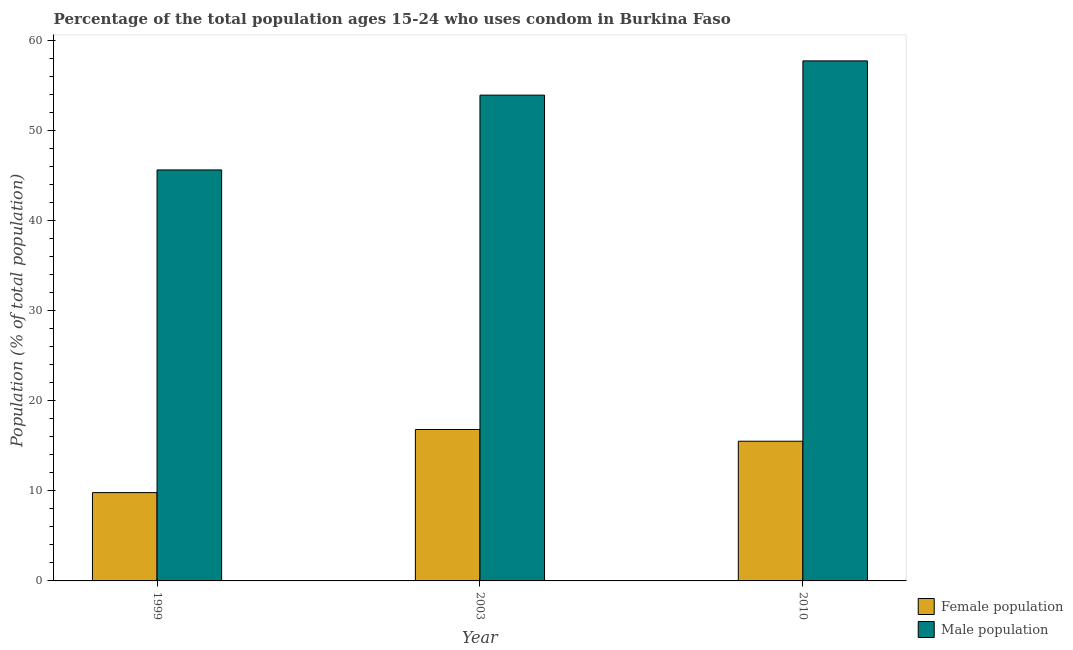How many groups of bars are there?
Ensure brevity in your answer.  3. Are the number of bars per tick equal to the number of legend labels?
Offer a terse response. Yes. Are the number of bars on each tick of the X-axis equal?
Give a very brief answer. Yes. How many bars are there on the 3rd tick from the left?
Provide a short and direct response. 2. In how many cases, is the number of bars for a given year not equal to the number of legend labels?
Give a very brief answer. 0. What is the female population in 2010?
Ensure brevity in your answer.  15.5. Across all years, what is the maximum male population?
Provide a short and direct response. 57.7. In which year was the female population minimum?
Keep it short and to the point. 1999. What is the total female population in the graph?
Provide a succinct answer. 42.1. What is the difference between the male population in 1999 and that in 2003?
Your response must be concise. -8.3. What is the difference between the male population in 2010 and the female population in 2003?
Give a very brief answer. 3.8. What is the average female population per year?
Provide a short and direct response. 14.03. In the year 2003, what is the difference between the male population and female population?
Your answer should be compact. 0. In how many years, is the female population greater than 12 %?
Your response must be concise. 2. What is the ratio of the male population in 1999 to that in 2003?
Offer a very short reply. 0.85. Is the difference between the male population in 1999 and 2010 greater than the difference between the female population in 1999 and 2010?
Your response must be concise. No. What is the difference between the highest and the second highest female population?
Offer a terse response. 1.3. What is the difference between the highest and the lowest male population?
Keep it short and to the point. 12.1. In how many years, is the female population greater than the average female population taken over all years?
Offer a very short reply. 2. What does the 1st bar from the left in 2003 represents?
Ensure brevity in your answer.  Female population. What does the 1st bar from the right in 2003 represents?
Ensure brevity in your answer.  Male population. How many bars are there?
Provide a succinct answer. 6. Are all the bars in the graph horizontal?
Provide a short and direct response. No. What is the difference between two consecutive major ticks on the Y-axis?
Make the answer very short. 10. How are the legend labels stacked?
Your response must be concise. Vertical. What is the title of the graph?
Provide a short and direct response. Percentage of the total population ages 15-24 who uses condom in Burkina Faso. What is the label or title of the X-axis?
Your response must be concise. Year. What is the label or title of the Y-axis?
Give a very brief answer. Population (% of total population) . What is the Population (% of total population)  of Male population in 1999?
Keep it short and to the point. 45.6. What is the Population (% of total population)  of Male population in 2003?
Your answer should be compact. 53.9. What is the Population (% of total population)  of Female population in 2010?
Provide a short and direct response. 15.5. What is the Population (% of total population)  of Male population in 2010?
Offer a terse response. 57.7. Across all years, what is the maximum Population (% of total population)  in Male population?
Ensure brevity in your answer.  57.7. Across all years, what is the minimum Population (% of total population)  of Male population?
Provide a short and direct response. 45.6. What is the total Population (% of total population)  in Female population in the graph?
Offer a very short reply. 42.1. What is the total Population (% of total population)  in Male population in the graph?
Your answer should be compact. 157.2. What is the difference between the Population (% of total population)  of Female population in 1999 and that in 2003?
Ensure brevity in your answer.  -7. What is the difference between the Population (% of total population)  in Male population in 1999 and that in 2010?
Provide a short and direct response. -12.1. What is the difference between the Population (% of total population)  in Female population in 1999 and the Population (% of total population)  in Male population in 2003?
Offer a terse response. -44.1. What is the difference between the Population (% of total population)  in Female population in 1999 and the Population (% of total population)  in Male population in 2010?
Give a very brief answer. -47.9. What is the difference between the Population (% of total population)  of Female population in 2003 and the Population (% of total population)  of Male population in 2010?
Your answer should be very brief. -40.9. What is the average Population (% of total population)  in Female population per year?
Provide a succinct answer. 14.03. What is the average Population (% of total population)  in Male population per year?
Keep it short and to the point. 52.4. In the year 1999, what is the difference between the Population (% of total population)  in Female population and Population (% of total population)  in Male population?
Provide a short and direct response. -35.8. In the year 2003, what is the difference between the Population (% of total population)  of Female population and Population (% of total population)  of Male population?
Provide a succinct answer. -37.1. In the year 2010, what is the difference between the Population (% of total population)  of Female population and Population (% of total population)  of Male population?
Give a very brief answer. -42.2. What is the ratio of the Population (% of total population)  in Female population in 1999 to that in 2003?
Keep it short and to the point. 0.58. What is the ratio of the Population (% of total population)  in Male population in 1999 to that in 2003?
Keep it short and to the point. 0.85. What is the ratio of the Population (% of total population)  in Female population in 1999 to that in 2010?
Provide a succinct answer. 0.63. What is the ratio of the Population (% of total population)  of Male population in 1999 to that in 2010?
Provide a short and direct response. 0.79. What is the ratio of the Population (% of total population)  of Female population in 2003 to that in 2010?
Your answer should be compact. 1.08. What is the ratio of the Population (% of total population)  in Male population in 2003 to that in 2010?
Make the answer very short. 0.93. What is the difference between the highest and the second highest Population (% of total population)  in Male population?
Make the answer very short. 3.8. What is the difference between the highest and the lowest Population (% of total population)  of Male population?
Make the answer very short. 12.1. 